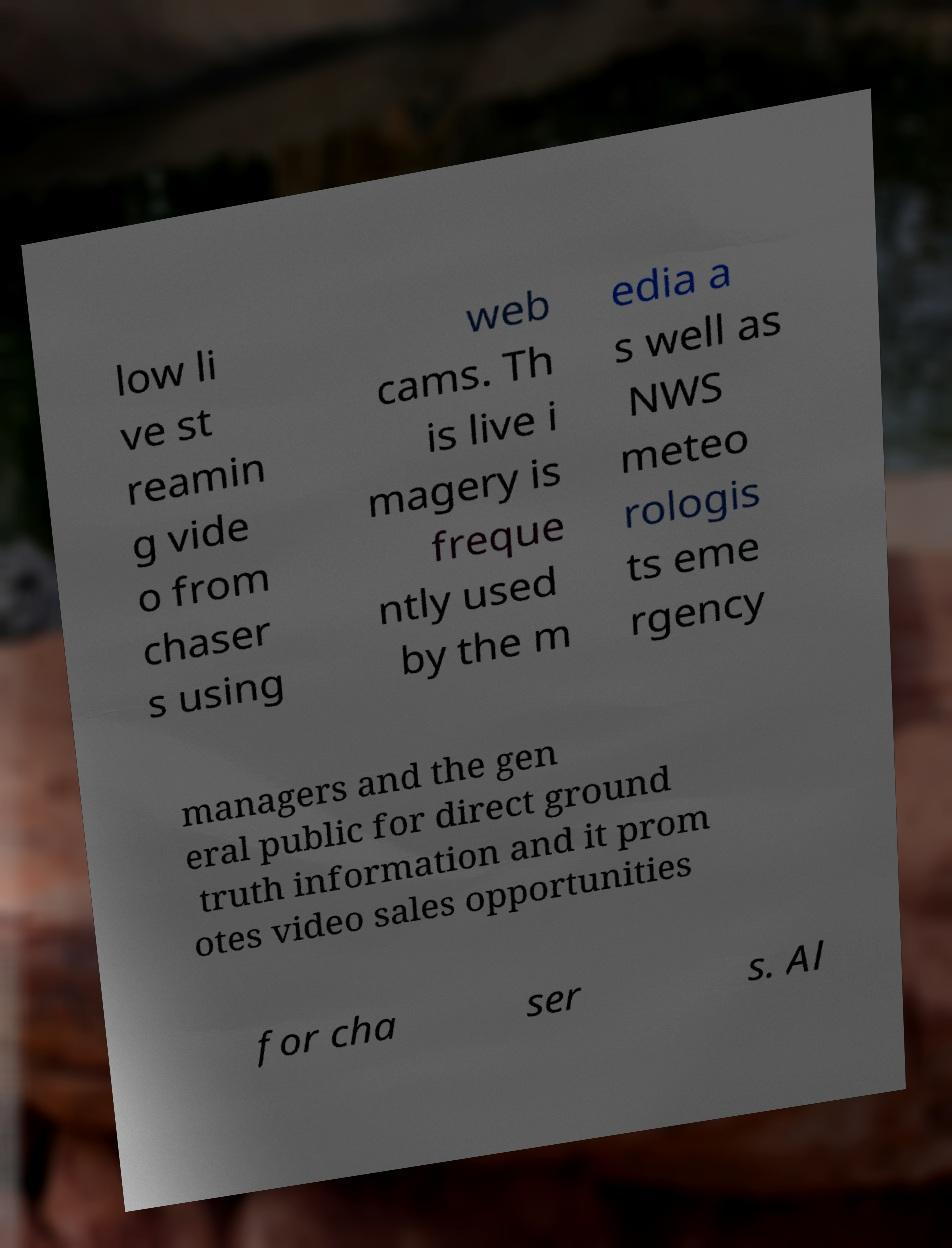Please identify and transcribe the text found in this image. low li ve st reamin g vide o from chaser s using web cams. Th is live i magery is freque ntly used by the m edia a s well as NWS meteo rologis ts eme rgency managers and the gen eral public for direct ground truth information and it prom otes video sales opportunities for cha ser s. Al 